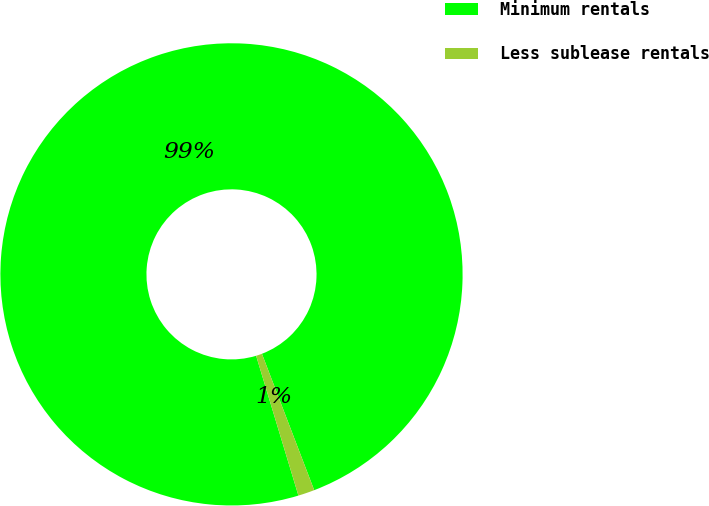<chart> <loc_0><loc_0><loc_500><loc_500><pie_chart><fcel>Minimum rentals<fcel>Less sublease rentals<nl><fcel>98.85%<fcel>1.15%<nl></chart> 